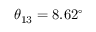<formula> <loc_0><loc_0><loc_500><loc_500>\theta _ { 1 3 } = 8 . 6 2 ^ { \circ }</formula> 